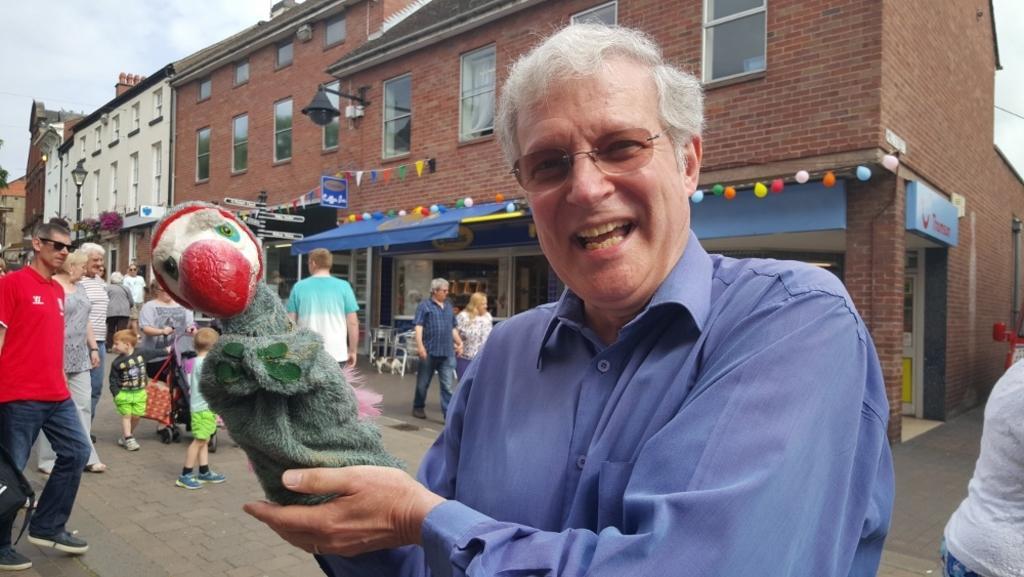Could you give a brief overview of what you see in this image? In this picture we can see a group of people walking on the road and a man holding an object with his hand, sunshade, balloons, buildings with windows and in the background we can see the sky with clouds. 